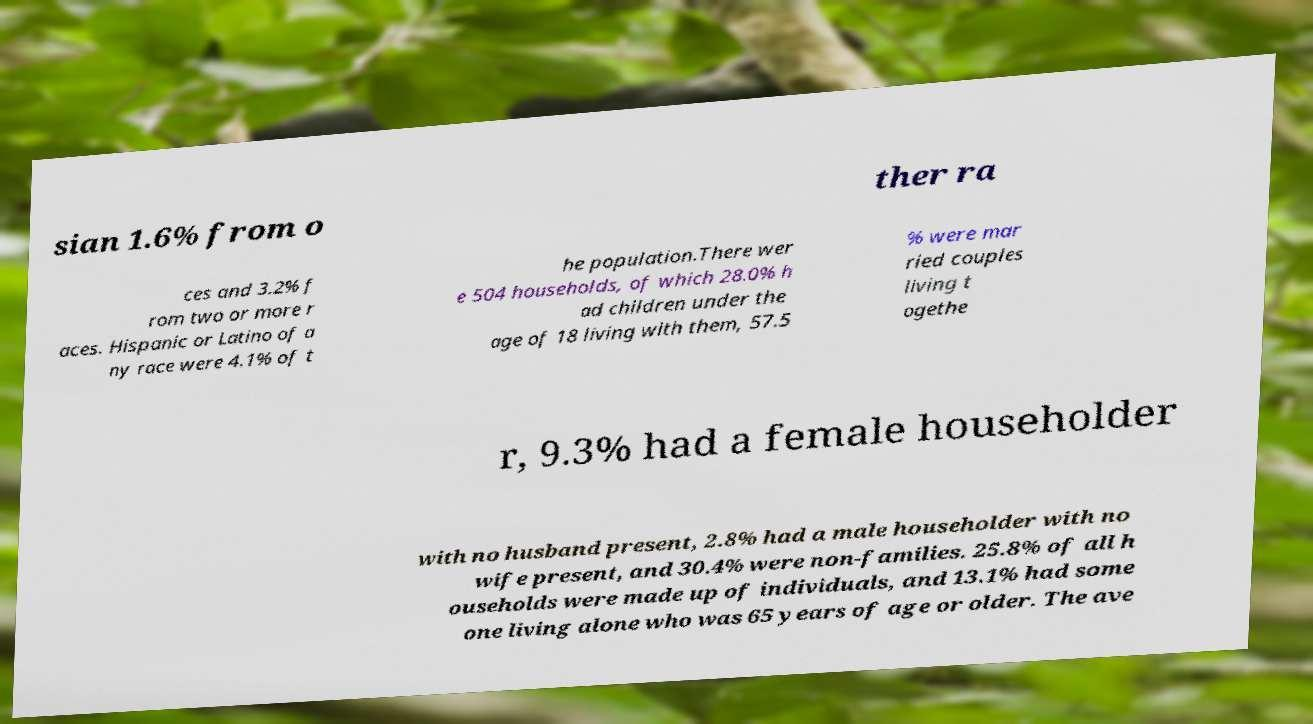Could you extract and type out the text from this image? sian 1.6% from o ther ra ces and 3.2% f rom two or more r aces. Hispanic or Latino of a ny race were 4.1% of t he population.There wer e 504 households, of which 28.0% h ad children under the age of 18 living with them, 57.5 % were mar ried couples living t ogethe r, 9.3% had a female householder with no husband present, 2.8% had a male householder with no wife present, and 30.4% were non-families. 25.8% of all h ouseholds were made up of individuals, and 13.1% had some one living alone who was 65 years of age or older. The ave 